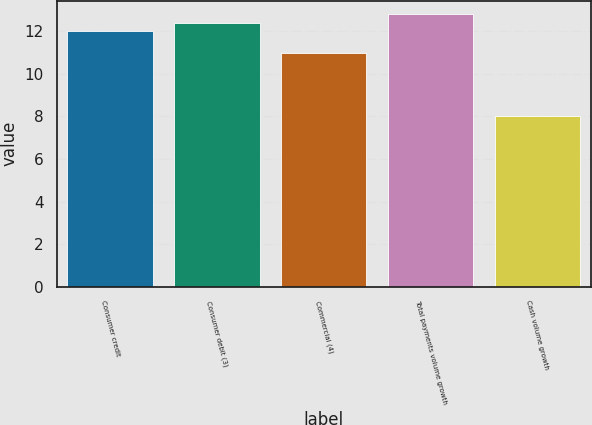<chart> <loc_0><loc_0><loc_500><loc_500><bar_chart><fcel>Consumer credit<fcel>Consumer debit (3)<fcel>Commercial (4)<fcel>Total payments volume growth<fcel>Cash volume growth<nl><fcel>12<fcel>12.4<fcel>11<fcel>12.8<fcel>8<nl></chart> 